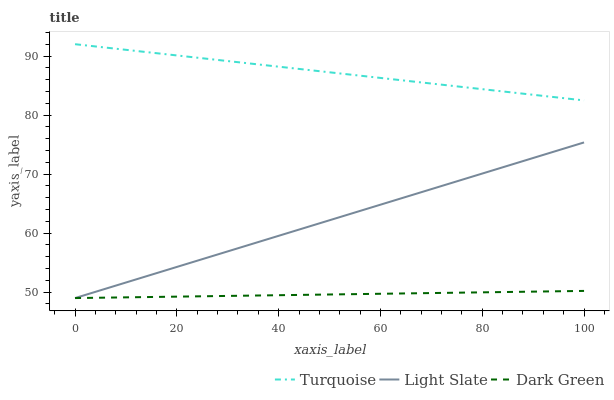Does Dark Green have the minimum area under the curve?
Answer yes or no. Yes. Does Turquoise have the maximum area under the curve?
Answer yes or no. Yes. Does Turquoise have the minimum area under the curve?
Answer yes or no. No. Does Dark Green have the maximum area under the curve?
Answer yes or no. No. Is Light Slate the smoothest?
Answer yes or no. Yes. Is Turquoise the roughest?
Answer yes or no. Yes. Is Dark Green the smoothest?
Answer yes or no. No. Is Dark Green the roughest?
Answer yes or no. No. Does Light Slate have the lowest value?
Answer yes or no. Yes. Does Turquoise have the lowest value?
Answer yes or no. No. Does Turquoise have the highest value?
Answer yes or no. Yes. Does Dark Green have the highest value?
Answer yes or no. No. Is Dark Green less than Turquoise?
Answer yes or no. Yes. Is Turquoise greater than Light Slate?
Answer yes or no. Yes. Does Light Slate intersect Dark Green?
Answer yes or no. Yes. Is Light Slate less than Dark Green?
Answer yes or no. No. Is Light Slate greater than Dark Green?
Answer yes or no. No. Does Dark Green intersect Turquoise?
Answer yes or no. No. 